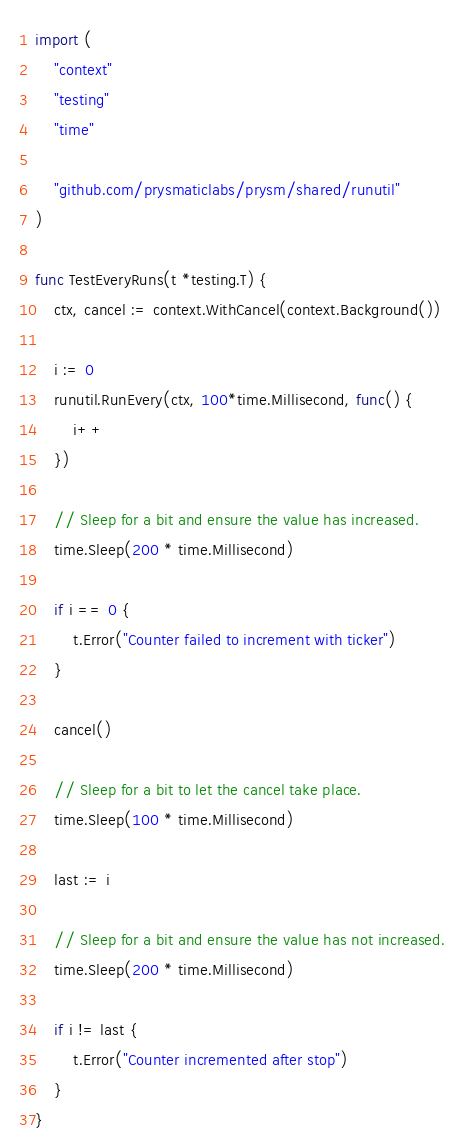<code> <loc_0><loc_0><loc_500><loc_500><_Go_>
import (
	"context"
	"testing"
	"time"

	"github.com/prysmaticlabs/prysm/shared/runutil"
)

func TestEveryRuns(t *testing.T) {
	ctx, cancel := context.WithCancel(context.Background())

	i := 0
	runutil.RunEvery(ctx, 100*time.Millisecond, func() {
		i++
	})

	// Sleep for a bit and ensure the value has increased.
	time.Sleep(200 * time.Millisecond)

	if i == 0 {
		t.Error("Counter failed to increment with ticker")
	}

	cancel()

	// Sleep for a bit to let the cancel take place.
	time.Sleep(100 * time.Millisecond)

	last := i

	// Sleep for a bit and ensure the value has not increased.
	time.Sleep(200 * time.Millisecond)

	if i != last {
		t.Error("Counter incremented after stop")
	}
}
</code> 